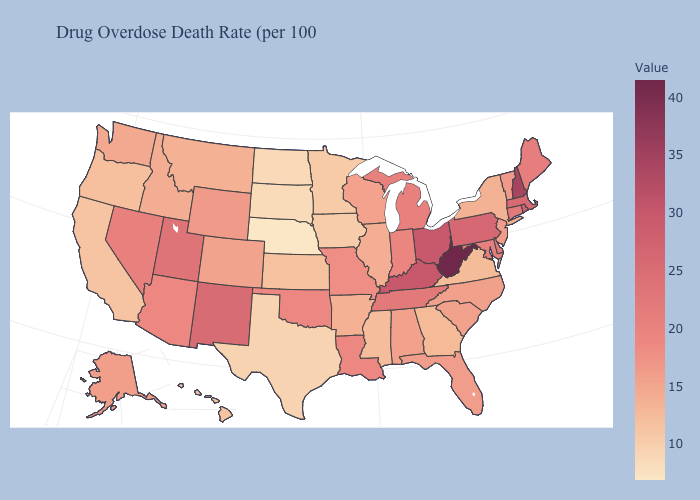Does Missouri have the highest value in the USA?
Give a very brief answer. No. Does South Dakota have the lowest value in the MidWest?
Keep it brief. No. Does Washington have the highest value in the USA?
Keep it brief. No. Which states hav the highest value in the South?
Be succinct. West Virginia. Is the legend a continuous bar?
Short answer required. Yes. 